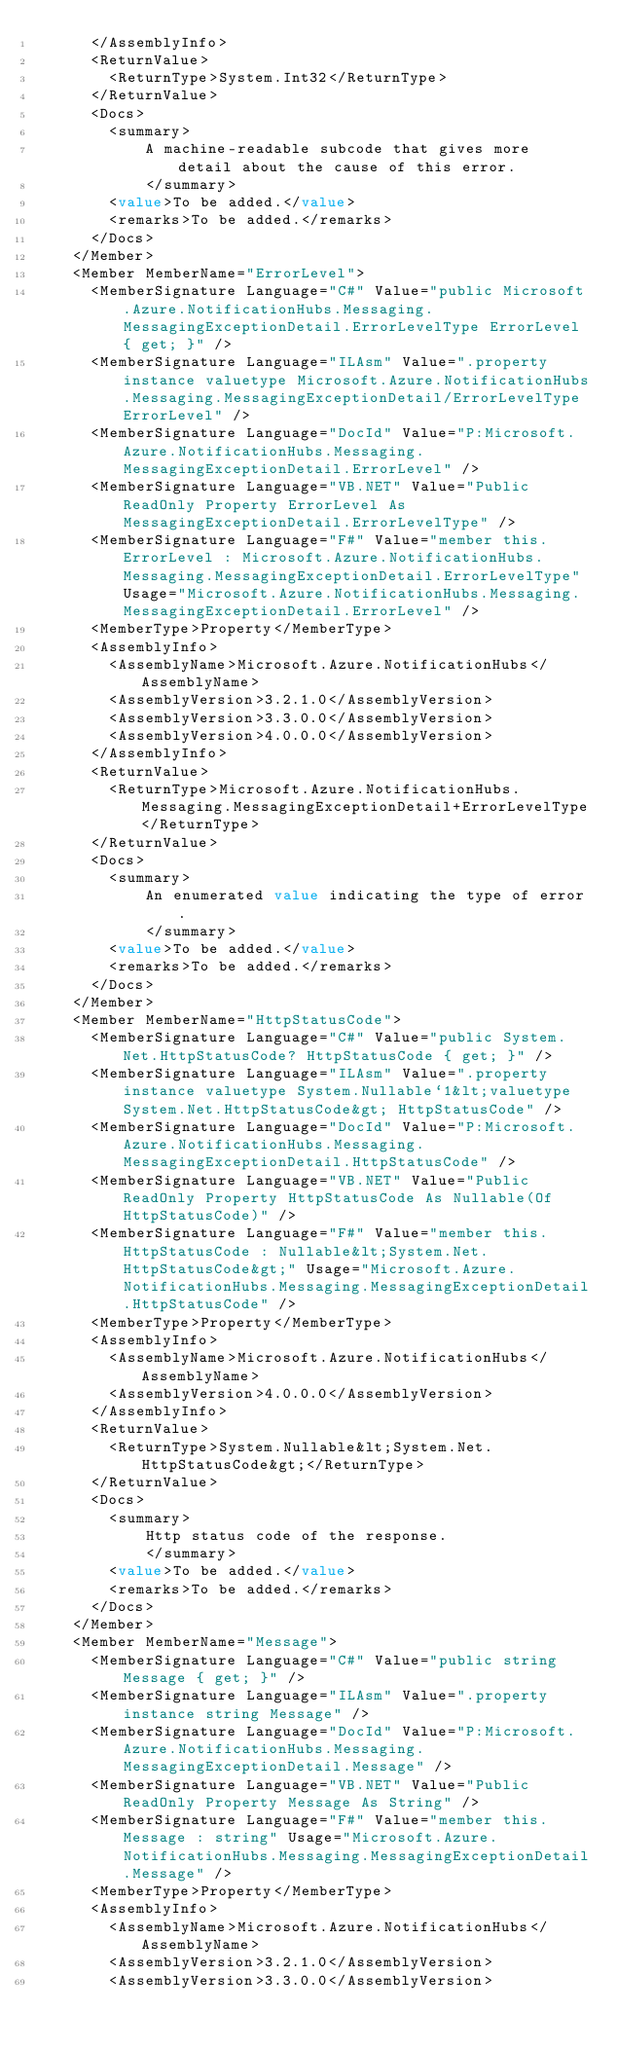Convert code to text. <code><loc_0><loc_0><loc_500><loc_500><_XML_>      </AssemblyInfo>
      <ReturnValue>
        <ReturnType>System.Int32</ReturnType>
      </ReturnValue>
      <Docs>
        <summary>
            A machine-readable subcode that gives more detail about the cause of this error.
            </summary>
        <value>To be added.</value>
        <remarks>To be added.</remarks>
      </Docs>
    </Member>
    <Member MemberName="ErrorLevel">
      <MemberSignature Language="C#" Value="public Microsoft.Azure.NotificationHubs.Messaging.MessagingExceptionDetail.ErrorLevelType ErrorLevel { get; }" />
      <MemberSignature Language="ILAsm" Value=".property instance valuetype Microsoft.Azure.NotificationHubs.Messaging.MessagingExceptionDetail/ErrorLevelType ErrorLevel" />
      <MemberSignature Language="DocId" Value="P:Microsoft.Azure.NotificationHubs.Messaging.MessagingExceptionDetail.ErrorLevel" />
      <MemberSignature Language="VB.NET" Value="Public ReadOnly Property ErrorLevel As MessagingExceptionDetail.ErrorLevelType" />
      <MemberSignature Language="F#" Value="member this.ErrorLevel : Microsoft.Azure.NotificationHubs.Messaging.MessagingExceptionDetail.ErrorLevelType" Usage="Microsoft.Azure.NotificationHubs.Messaging.MessagingExceptionDetail.ErrorLevel" />
      <MemberType>Property</MemberType>
      <AssemblyInfo>
        <AssemblyName>Microsoft.Azure.NotificationHubs</AssemblyName>
        <AssemblyVersion>3.2.1.0</AssemblyVersion>
        <AssemblyVersion>3.3.0.0</AssemblyVersion>
        <AssemblyVersion>4.0.0.0</AssemblyVersion>
      </AssemblyInfo>
      <ReturnValue>
        <ReturnType>Microsoft.Azure.NotificationHubs.Messaging.MessagingExceptionDetail+ErrorLevelType</ReturnType>
      </ReturnValue>
      <Docs>
        <summary>
            An enumerated value indicating the type of error.
            </summary>
        <value>To be added.</value>
        <remarks>To be added.</remarks>
      </Docs>
    </Member>
    <Member MemberName="HttpStatusCode">
      <MemberSignature Language="C#" Value="public System.Net.HttpStatusCode? HttpStatusCode { get; }" />
      <MemberSignature Language="ILAsm" Value=".property instance valuetype System.Nullable`1&lt;valuetype System.Net.HttpStatusCode&gt; HttpStatusCode" />
      <MemberSignature Language="DocId" Value="P:Microsoft.Azure.NotificationHubs.Messaging.MessagingExceptionDetail.HttpStatusCode" />
      <MemberSignature Language="VB.NET" Value="Public ReadOnly Property HttpStatusCode As Nullable(Of HttpStatusCode)" />
      <MemberSignature Language="F#" Value="member this.HttpStatusCode : Nullable&lt;System.Net.HttpStatusCode&gt;" Usage="Microsoft.Azure.NotificationHubs.Messaging.MessagingExceptionDetail.HttpStatusCode" />
      <MemberType>Property</MemberType>
      <AssemblyInfo>
        <AssemblyName>Microsoft.Azure.NotificationHubs</AssemblyName>
        <AssemblyVersion>4.0.0.0</AssemblyVersion>
      </AssemblyInfo>
      <ReturnValue>
        <ReturnType>System.Nullable&lt;System.Net.HttpStatusCode&gt;</ReturnType>
      </ReturnValue>
      <Docs>
        <summary>
            Http status code of the response.
            </summary>
        <value>To be added.</value>
        <remarks>To be added.</remarks>
      </Docs>
    </Member>
    <Member MemberName="Message">
      <MemberSignature Language="C#" Value="public string Message { get; }" />
      <MemberSignature Language="ILAsm" Value=".property instance string Message" />
      <MemberSignature Language="DocId" Value="P:Microsoft.Azure.NotificationHubs.Messaging.MessagingExceptionDetail.Message" />
      <MemberSignature Language="VB.NET" Value="Public ReadOnly Property Message As String" />
      <MemberSignature Language="F#" Value="member this.Message : string" Usage="Microsoft.Azure.NotificationHubs.Messaging.MessagingExceptionDetail.Message" />
      <MemberType>Property</MemberType>
      <AssemblyInfo>
        <AssemblyName>Microsoft.Azure.NotificationHubs</AssemblyName>
        <AssemblyVersion>3.2.1.0</AssemblyVersion>
        <AssemblyVersion>3.3.0.0</AssemblyVersion></code> 